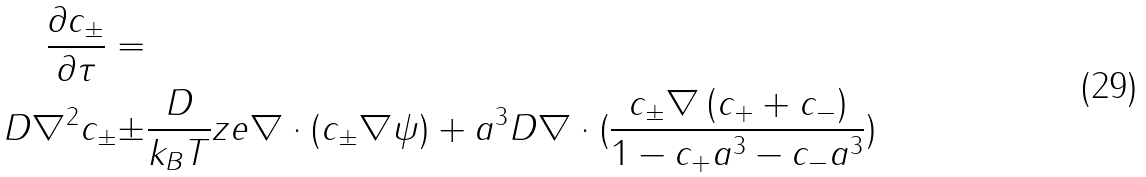Convert formula to latex. <formula><loc_0><loc_0><loc_500><loc_500>\frac { \partial c _ { \pm } } { \partial \tau } = & \\ D \nabla ^ { 2 } c _ { \pm } \pm & \frac { D } { k _ { B } T } z e \nabla \cdot ( c _ { \pm } \nabla \psi ) + a ^ { 3 } D \nabla \cdot ( \frac { c _ { \pm } \nabla \left ( c _ { + } + c _ { - } \right ) } { 1 - c _ { + } a ^ { 3 } - c _ { - } a ^ { 3 } } )</formula> 